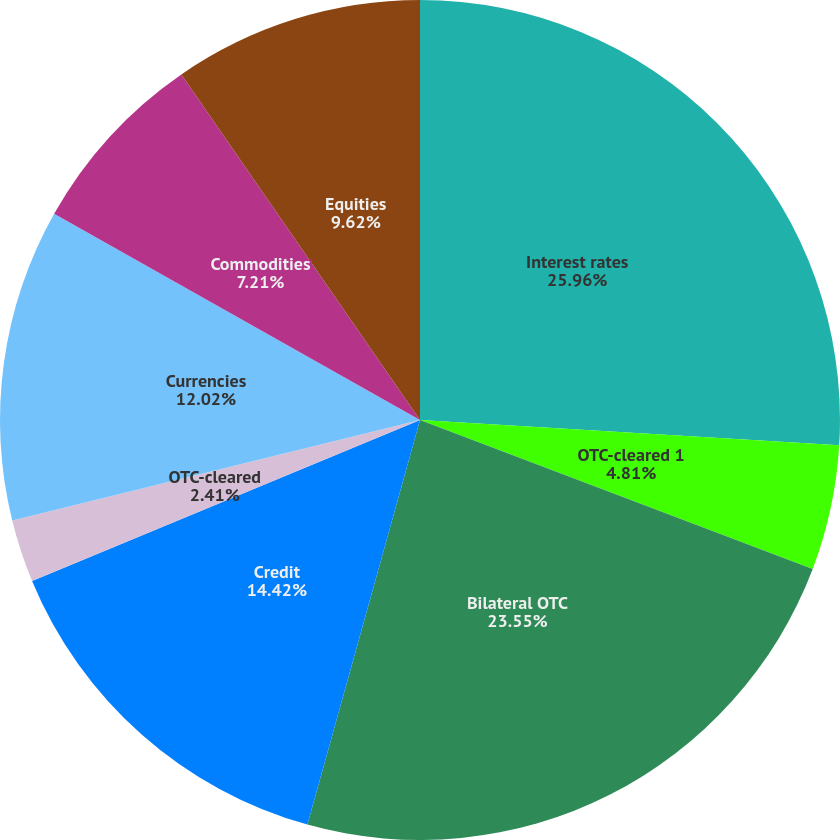<chart> <loc_0><loc_0><loc_500><loc_500><pie_chart><fcel>Interest rates<fcel>Exchange-traded<fcel>OTC-cleared 1<fcel>Bilateral OTC<fcel>Credit<fcel>OTC-cleared<fcel>Currencies<fcel>Commodities<fcel>Equities<nl><fcel>25.96%<fcel>0.0%<fcel>4.81%<fcel>23.55%<fcel>14.42%<fcel>2.41%<fcel>12.02%<fcel>7.21%<fcel>9.62%<nl></chart> 